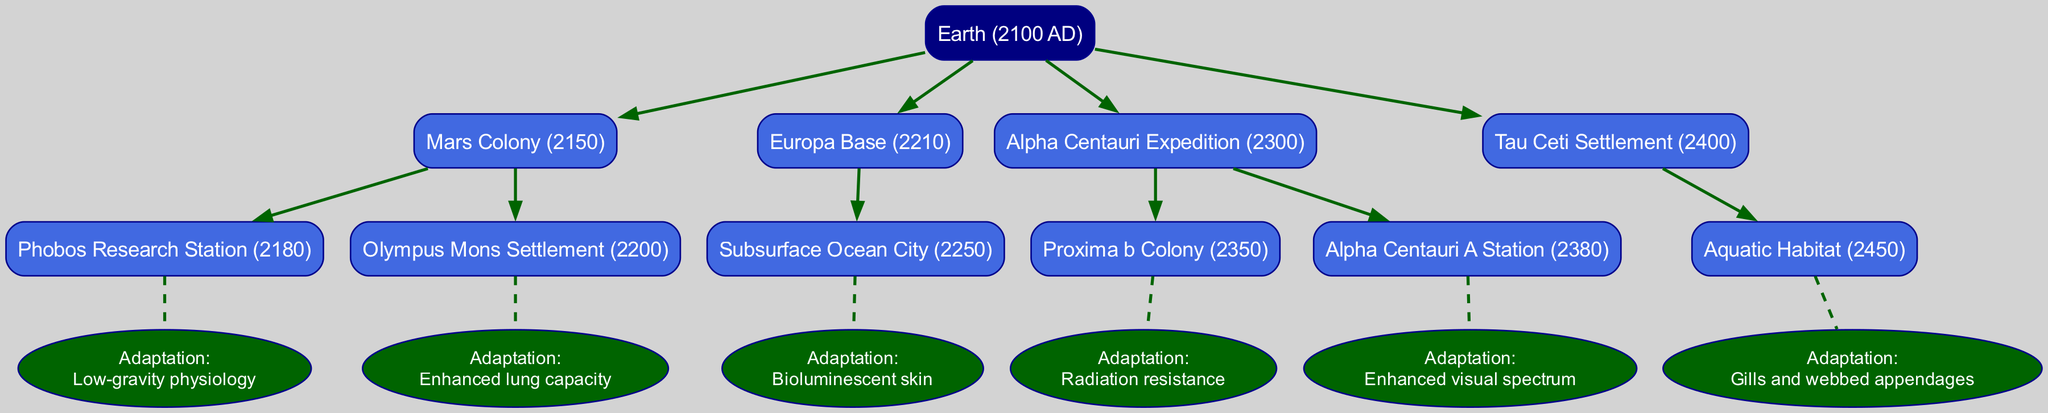What is the first human colony established after Earth? The diagram indicates that the first human colony established after Earth is the Mars Colony in 2150. This information is shown as the first child node under the root node (Earth).
Answer: Mars Colony How many adaptations are listed under the Alpha Centauri Expedition? The Alpha Centauri Expedition has two listed adaptations: "Radiation resistance" and "Enhanced visual spectrum." This is seen by examining the children of the Alpha Centauri Expedition node.
Answer: 2 Which colony is known for having bioluminescent skin as an adaptation? The Europa Base, specifically its child node Subsurface Ocean City, is noted for its adaptation of bioluminescent skin. This is evident in the adaptation details connected to the Subsurface Ocean City node.
Answer: Subsurface Ocean City What is the adaptation associated with the Aquatic Habitat? The adaptation associated with the Aquatic Habitat is "Gills and webbed appendages." This is directly shown under the child node of the Tau Ceti Settlement.
Answer: Gills and webbed appendages What year was the Proxima b Colony established? The Proxima b Colony was established in 2350, as denoted by the child node under the Alpha Centauri Expedition.
Answer: 2350 Which colony has the adaptation of "Enhanced lung capacity"? The adaptation of "Enhanced lung capacity" is associated with the Olympus Mons Settlement, which is a child node under the Mars Colony.
Answer: Olympus Mons Settlement What is the root node of the family tree? The root node of the family tree is Earth, as indicated at the top of the diagram where the colonization timeline begins.
Answer: Earth How many total child nodes does the Mars Colony have? The Mars Colony has two child nodes: Phobos Research Station and Olympus Mons Settlement. This can be counted by looking at its direct children in the diagram.
Answer: 2 